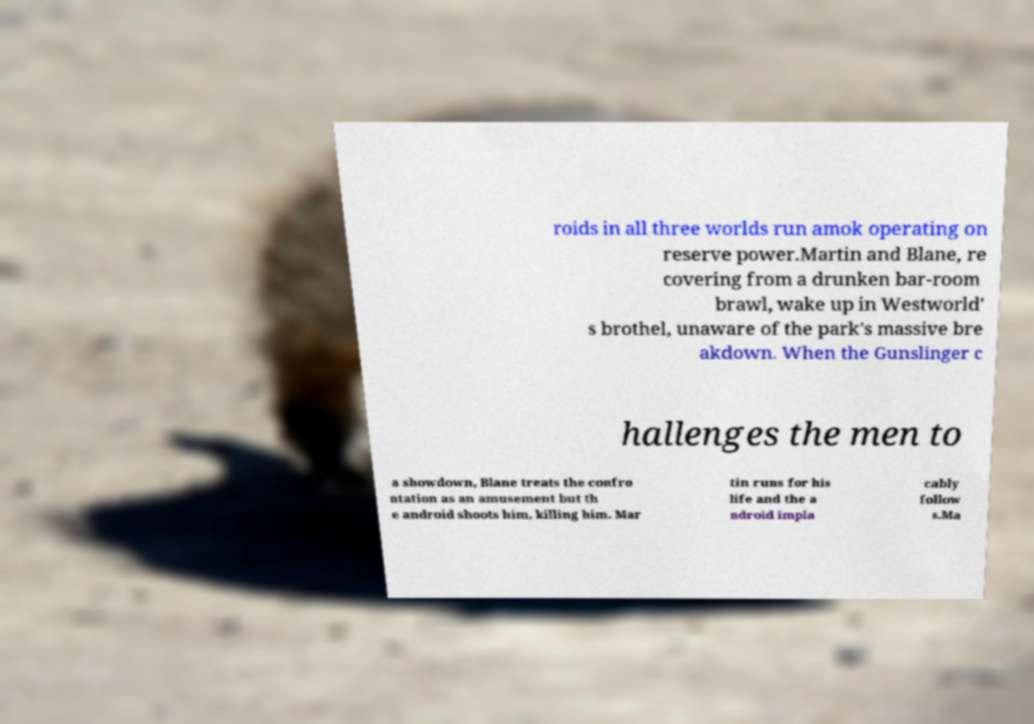What messages or text are displayed in this image? I need them in a readable, typed format. roids in all three worlds run amok operating on reserve power.Martin and Blane, re covering from a drunken bar-room brawl, wake up in Westworld' s brothel, unaware of the park's massive bre akdown. When the Gunslinger c hallenges the men to a showdown, Blane treats the confro ntation as an amusement but th e android shoots him, killing him. Mar tin runs for his life and the a ndroid impla cably follow s.Ma 